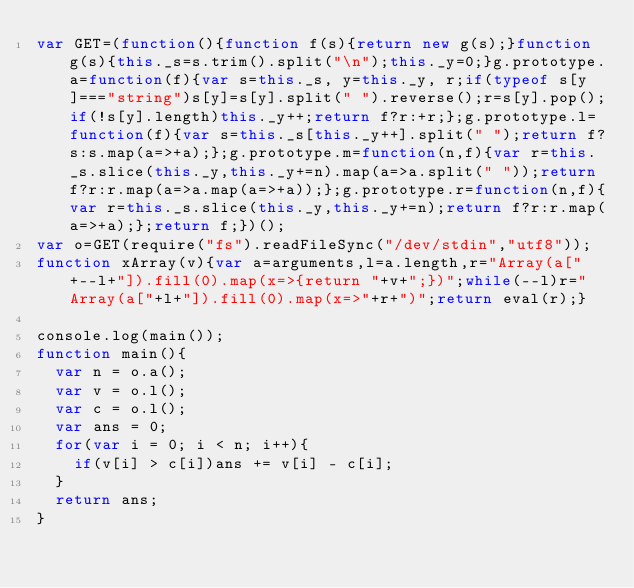Convert code to text. <code><loc_0><loc_0><loc_500><loc_500><_JavaScript_>var GET=(function(){function f(s){return new g(s);}function g(s){this._s=s.trim().split("\n");this._y=0;}g.prototype.a=function(f){var s=this._s, y=this._y, r;if(typeof s[y]==="string")s[y]=s[y].split(" ").reverse();r=s[y].pop();if(!s[y].length)this._y++;return f?r:+r;};g.prototype.l=function(f){var s=this._s[this._y++].split(" ");return f?s:s.map(a=>+a);};g.prototype.m=function(n,f){var r=this._s.slice(this._y,this._y+=n).map(a=>a.split(" "));return f?r:r.map(a=>a.map(a=>+a));};g.prototype.r=function(n,f){var r=this._s.slice(this._y,this._y+=n);return f?r:r.map(a=>+a);};return f;})();
var o=GET(require("fs").readFileSync("/dev/stdin","utf8"));
function xArray(v){var a=arguments,l=a.length,r="Array(a["+--l+"]).fill(0).map(x=>{return "+v+";})";while(--l)r="Array(a["+l+"]).fill(0).map(x=>"+r+")";return eval(r);}

console.log(main());
function main(){
  var n = o.a();
  var v = o.l();
  var c = o.l();
  var ans = 0;
  for(var i = 0; i < n; i++){
    if(v[i] > c[i])ans += v[i] - c[i];
  }
  return ans;
}</code> 